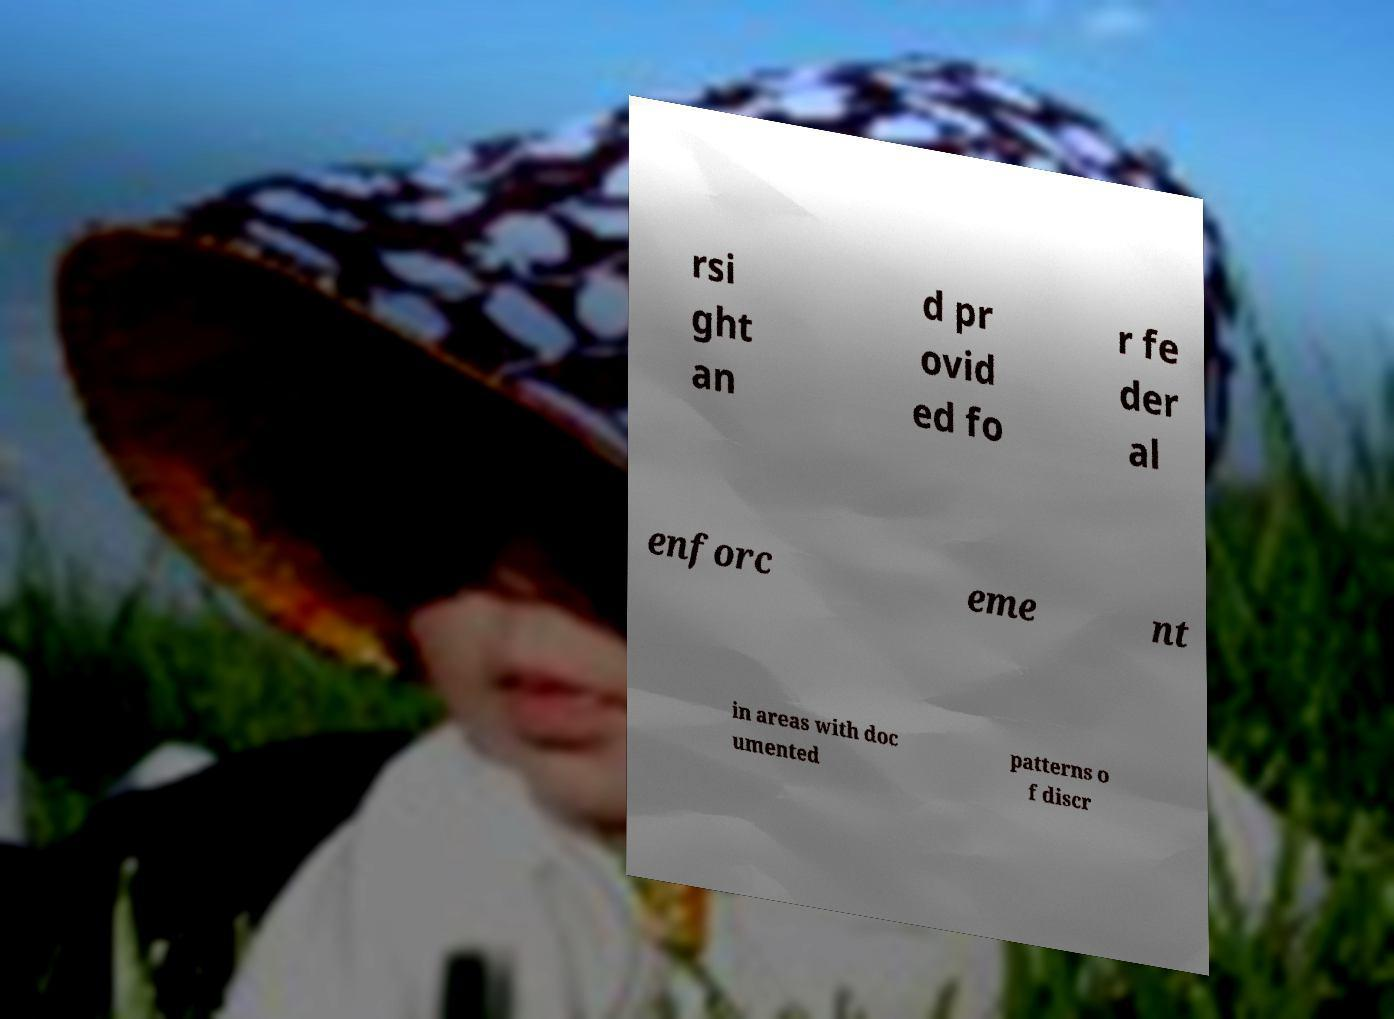Could you extract and type out the text from this image? rsi ght an d pr ovid ed fo r fe der al enforc eme nt in areas with doc umented patterns o f discr 